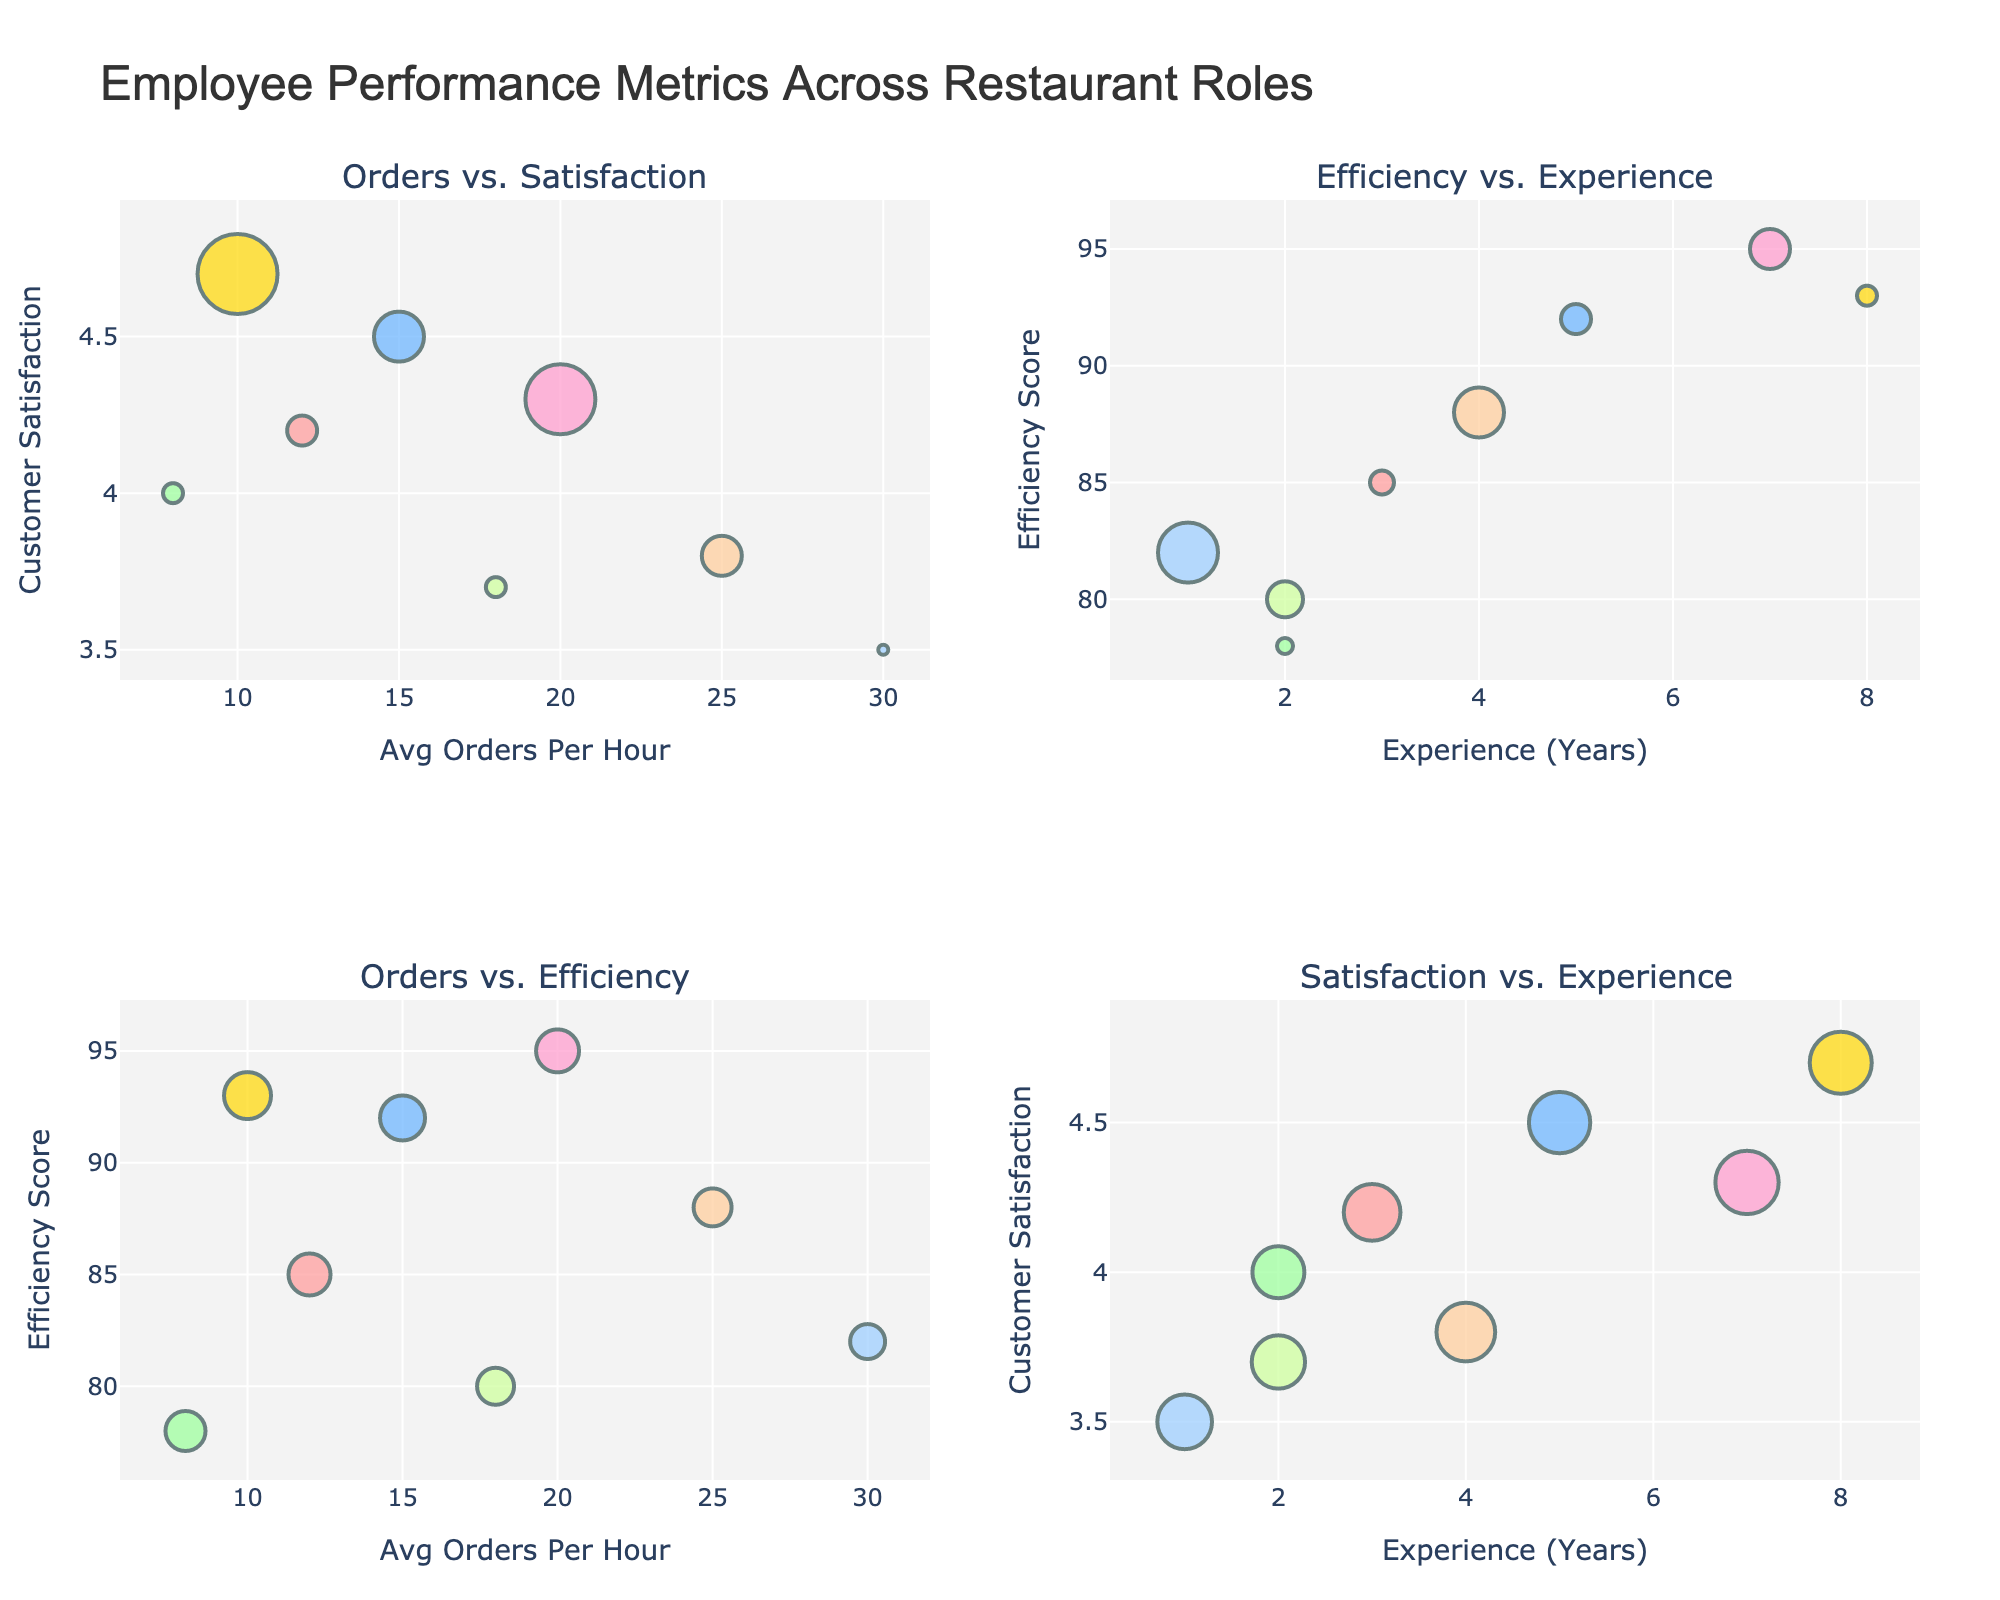what is the title of the figure? The title of the figure is displayed at the top of the plot window. It reads "Employee Performance Metrics Across Restaurant Roles."
Answer: Employee Performance Metrics Across Restaurant Roles How many subplots are there in the figure? The figure contains a grid of subplots arranged in 2 rows and 2 columns, resulting in a total of 4 subplots.
Answer: 4 Which role has the highest customer satisfaction? Look at the subplot titled "Orders vs. Satisfaction" and locate the bubble that is highest up on the y-axis labeled "Customer Satisfaction." The role associated with this bubble is shown in the hover text. The Manager role has the highest customer satisfaction.
Answer: Manager How does experience impact efficiency? Examine the subplot titled "Efficiency vs. Experience." On the x-axis labeled "Experience (Years)" and the y-axis labeled "Efficiency Score," observe the pattern of bubbles. There is an upward trend, suggesting that as years of experience increase, efficiency tends to also increase.
Answer: Increases Which role has the largest bubble size in the "Orders vs. Satisfaction" subplot? In the subplot "Orders vs. Satisfaction," the bubble sizes are determined by the "Experience_Years" column. The Dishwasher bubble is the largest due to having the maximum of 30 Avg Orders Per Hour.
Answer: Dishwasher What is the average customer satisfaction across all roles? To find this, sum up each of the customer satisfaction scores and divide by the number of roles. The satisfaction scores are 4.2, 4.5, 4.0, 3.8, 4.3, 3.5, 3.7, and 4.7. Adding these together gives 32.7, and dividing by 8 roles results in an average of 4.0875.
Answer: 4.0875 Which role has the highest efficiency score, and what is its score? By looking at the Efficiency vs Experience subplot and identifying the highest bubble on the y-axis "Efficiency Score," you see that the Sous Chef has the highest efficiency score of 95.
Answer: Sous Chef, 95 